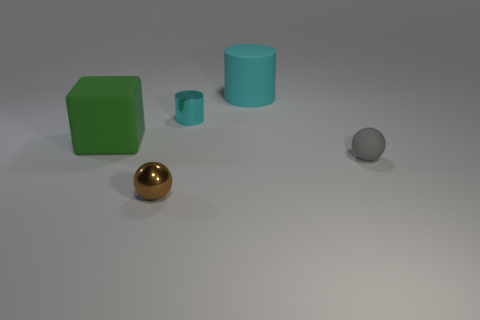Add 4 yellow shiny balls. How many objects exist? 9 Subtract all cylinders. How many objects are left? 3 Subtract 0 red cylinders. How many objects are left? 5 Subtract all large cyan rubber spheres. Subtract all big cylinders. How many objects are left? 4 Add 1 tiny brown metal balls. How many tiny brown metal balls are left? 2 Add 3 tiny matte spheres. How many tiny matte spheres exist? 4 